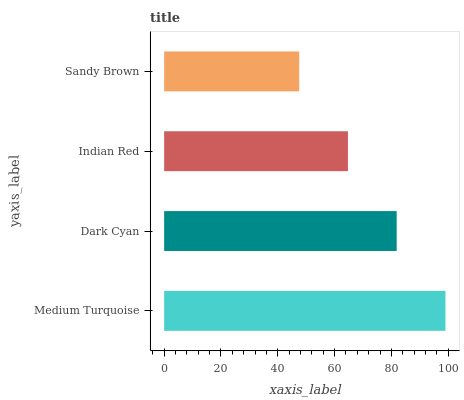Is Sandy Brown the minimum?
Answer yes or no. Yes. Is Medium Turquoise the maximum?
Answer yes or no. Yes. Is Dark Cyan the minimum?
Answer yes or no. No. Is Dark Cyan the maximum?
Answer yes or no. No. Is Medium Turquoise greater than Dark Cyan?
Answer yes or no. Yes. Is Dark Cyan less than Medium Turquoise?
Answer yes or no. Yes. Is Dark Cyan greater than Medium Turquoise?
Answer yes or no. No. Is Medium Turquoise less than Dark Cyan?
Answer yes or no. No. Is Dark Cyan the high median?
Answer yes or no. Yes. Is Indian Red the low median?
Answer yes or no. Yes. Is Sandy Brown the high median?
Answer yes or no. No. Is Dark Cyan the low median?
Answer yes or no. No. 